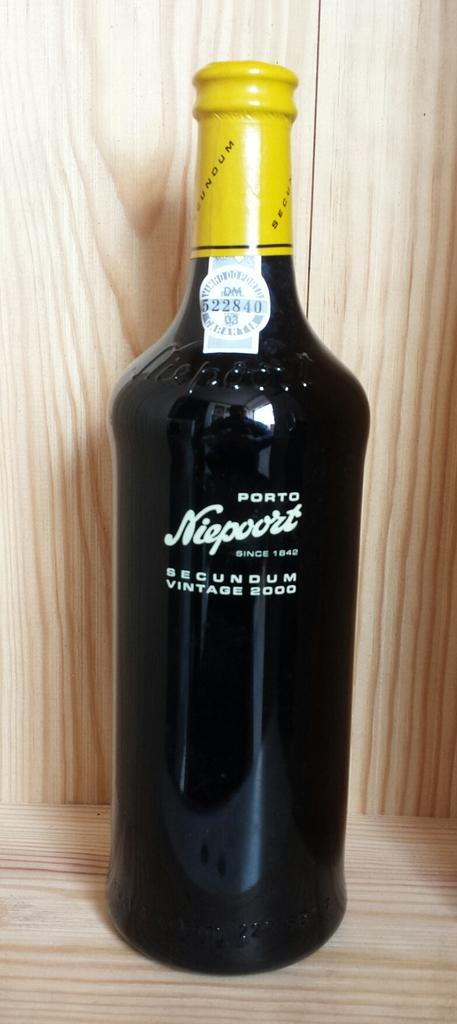<image>
Present a compact description of the photo's key features. A bottle of Port Niepoort from 2000 has a bright yellow wrapper at the top. 